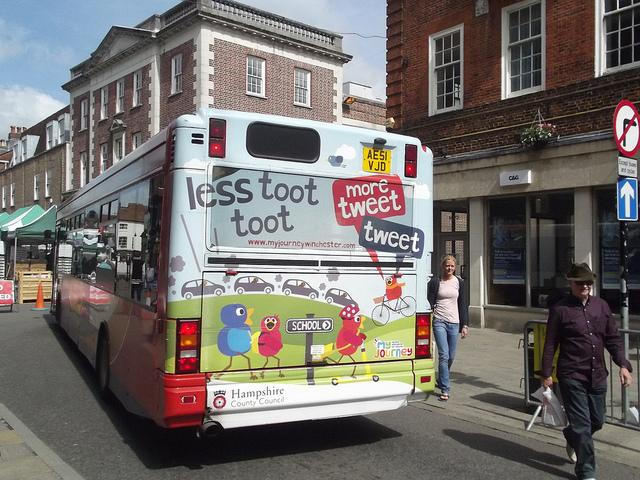Which direction will the bus go next?

Choices:
A) turn right
B) go straight
C) turn left
D) back up back up 